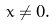<formula> <loc_0><loc_0><loc_500><loc_500>x \neq 0 .</formula> 